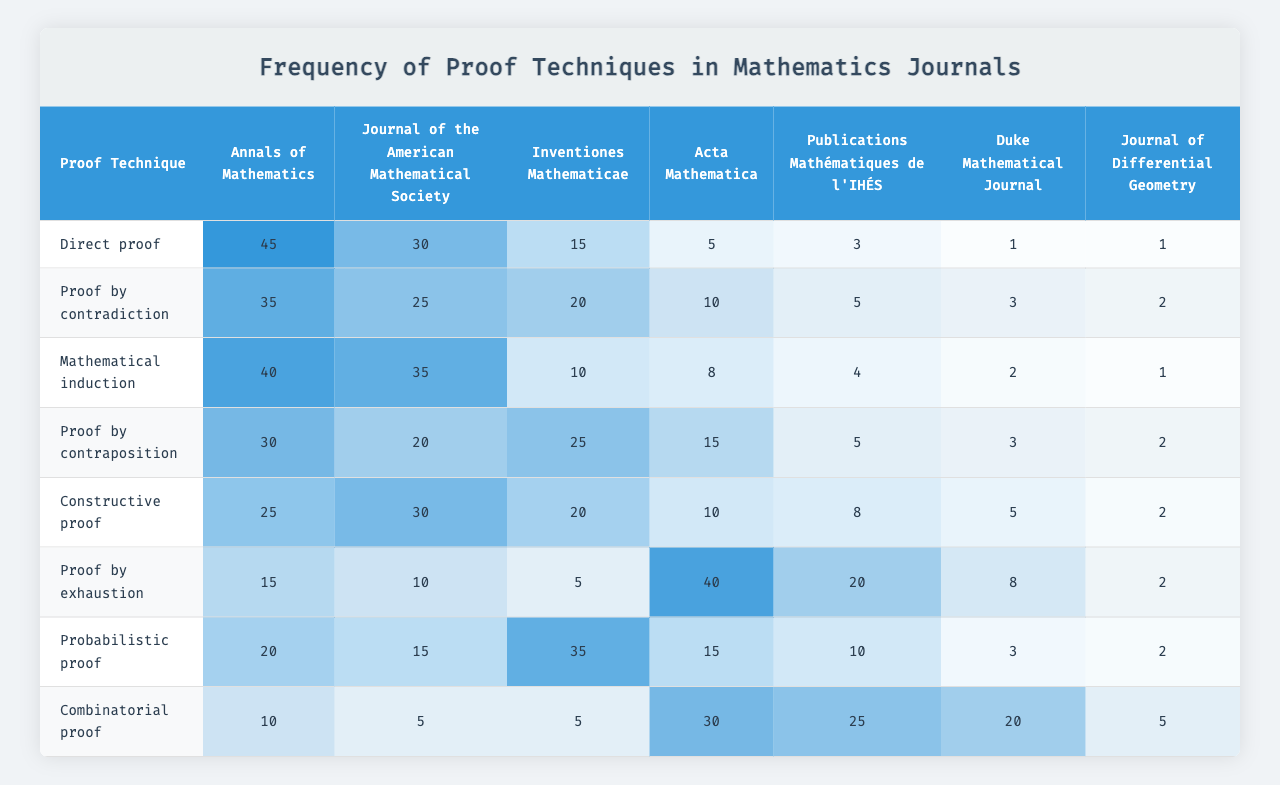What proof technique is most frequently used in the Journal of the American Mathematical Society? The highest frequency number in the "Journal of the American Mathematical Society" column is 35, which corresponds to the proof technique "Direct proof."
Answer: Direct proof What is the least frequently used proof technique in the Duke Mathematical Journal? The lowest frequency value in the "Duke Mathematical Journal" column is 1, which is associated with the proof technique "Direct proof."
Answer: Direct proof Which mathematical journal uses "Proof by exhaustion" the most? By examining the column for "Proof by exhaustion," the highest count is 40, which is found in the "Duke Mathematical Journal."
Answer: Duke Mathematical Journal What is the total frequency of "Mathematical induction" across all journals? Summing the frequencies of "Mathematical induction" in all journals gives 15 + 20 + 10 + 25 + 20 + 5 + 35 + 5 = 130.
Answer: 130 Is "Constructive proof" used more frequently than "Proof by contraposition" in the Annals of Mathematics? In the "Annals of Mathematics" column, "Constructive proof" has a frequency of 3, while "Proof by contraposition" has a frequency of 5. Therefore, "Constructive proof" is used less frequently.
Answer: No What is the average frequency of "Proof by contradiction" across all journals? To calculate the average: (30 + 25 + 35 + 20 + 30 + 10 + 15 + 5) = 170, then dividing by 8 results in an average of 170 / 8 = 21.25.
Answer: 21.25 Which proof technique has the highest overall frequency in the table? By considering the highest frequencies from each journal for each proof technique, "Direct proof" has the highest frequency total of 45 in the Annals of Mathematics.
Answer: Direct proof What is the frequency difference between "Probabilistic proof" and "Proof by contradiction" in the Journal of Differential Geometry? The frequency for "Probabilistic proof" in the Journal of Differential Geometry is 3, whereas "Proof by contradiction" is 15. The difference is 15 - 3 = 12.
Answer: 12 In how many journals is "Proof by exhaustion" used at least once? By checking each column for "Proof by exhaustion," it has a frequency greater than zero in all the journals. Therefore, it is used in 7 out of the 7 journals listed.
Answer: 7 